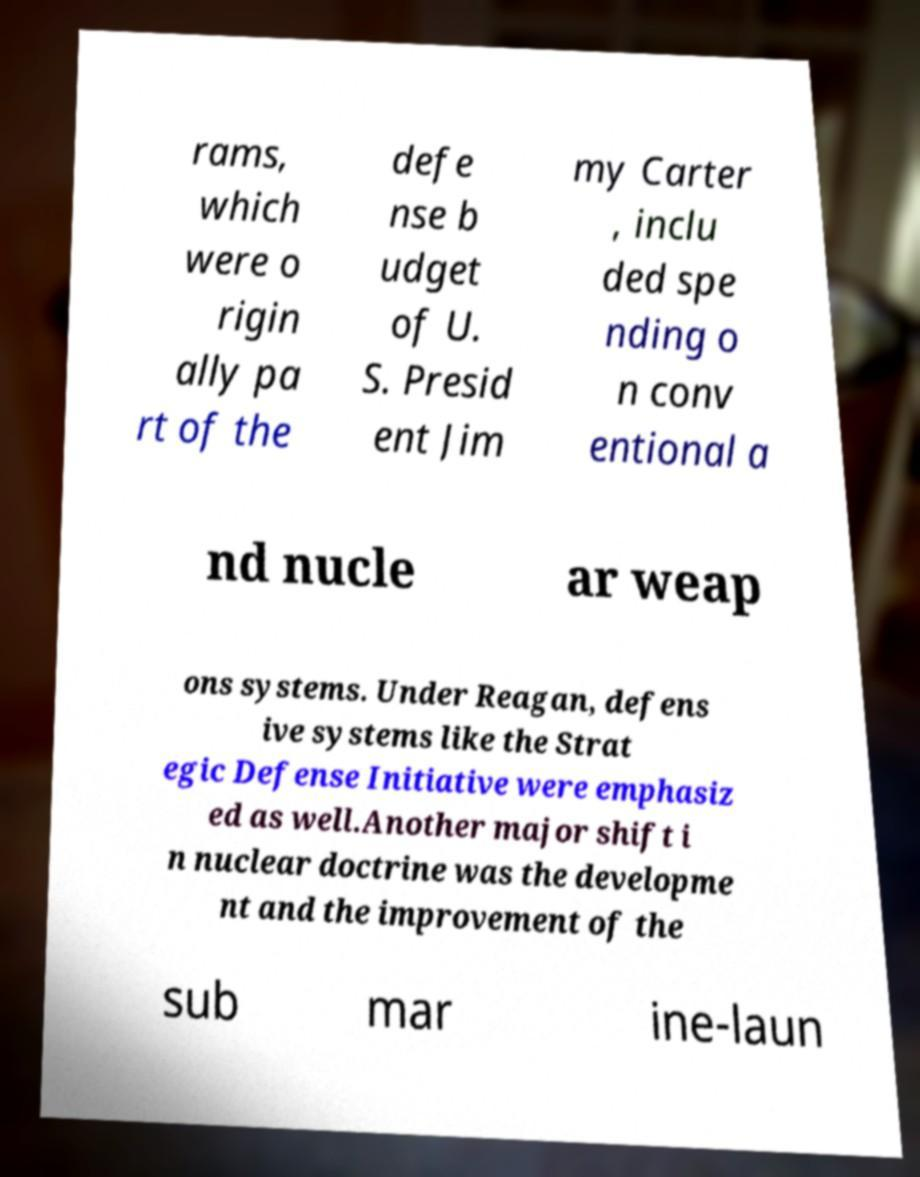Could you assist in decoding the text presented in this image and type it out clearly? rams, which were o rigin ally pa rt of the defe nse b udget of U. S. Presid ent Jim my Carter , inclu ded spe nding o n conv entional a nd nucle ar weap ons systems. Under Reagan, defens ive systems like the Strat egic Defense Initiative were emphasiz ed as well.Another major shift i n nuclear doctrine was the developme nt and the improvement of the sub mar ine-laun 